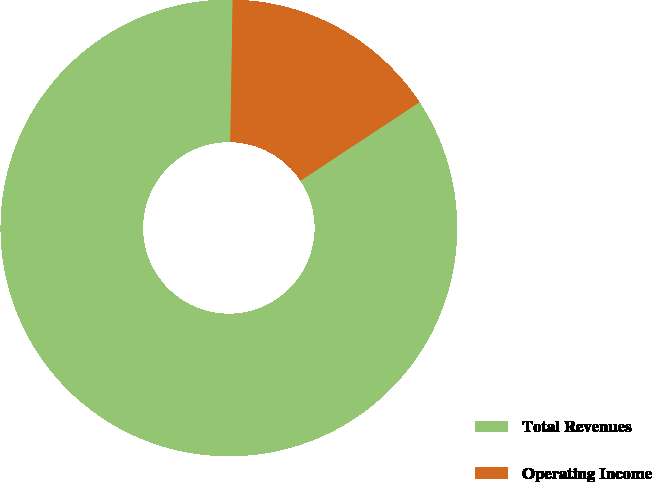<chart> <loc_0><loc_0><loc_500><loc_500><pie_chart><fcel>Total Revenues<fcel>Operating Income<nl><fcel>84.55%<fcel>15.45%<nl></chart> 